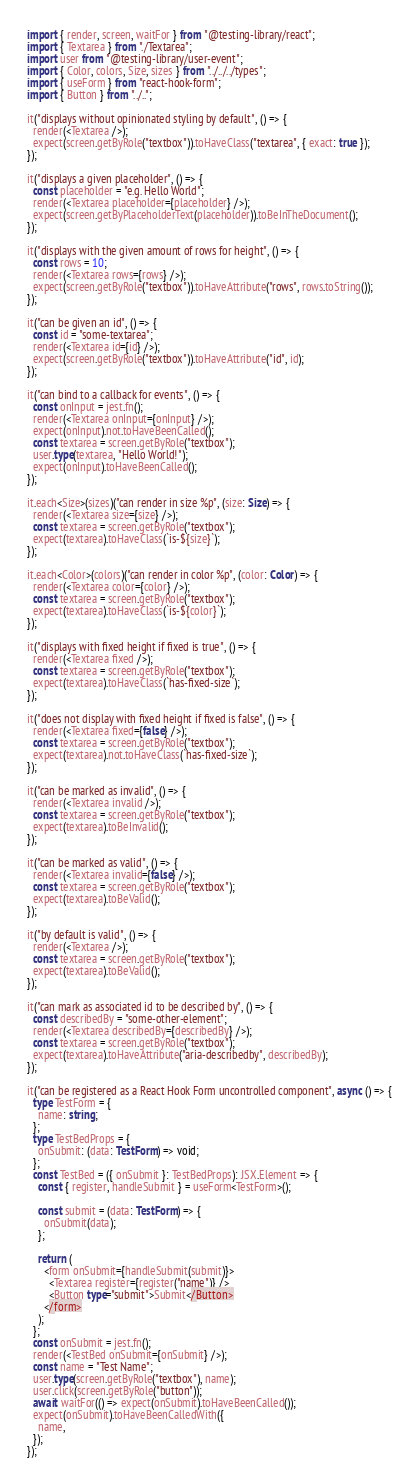Convert code to text. <code><loc_0><loc_0><loc_500><loc_500><_TypeScript_>import { render, screen, waitFor } from "@testing-library/react";
import { Textarea } from "./Textarea";
import user from "@testing-library/user-event";
import { Color, colors, Size, sizes } from "../../../types";
import { useForm } from "react-hook-form";
import { Button } from "../..";

it("displays without opinionated styling by default", () => {
  render(<Textarea />);
  expect(screen.getByRole("textbox")).toHaveClass("textarea", { exact: true });
});

it("displays a given placeholder", () => {
  const placeholder = "e.g. Hello World";
  render(<Textarea placeholder={placeholder} />);
  expect(screen.getByPlaceholderText(placeholder)).toBeInTheDocument();
});

it("displays with the given amount of rows for height", () => {
  const rows = 10;
  render(<Textarea rows={rows} />);
  expect(screen.getByRole("textbox")).toHaveAttribute("rows", rows.toString());
});

it("can be given an id", () => {
  const id = "some-textarea";
  render(<Textarea id={id} />);
  expect(screen.getByRole("textbox")).toHaveAttribute("id", id);
});

it("can bind to a callback for events", () => {
  const onInput = jest.fn();
  render(<Textarea onInput={onInput} />);
  expect(onInput).not.toHaveBeenCalled();
  const textarea = screen.getByRole("textbox");
  user.type(textarea, "Hello World!");
  expect(onInput).toHaveBeenCalled();
});

it.each<Size>(sizes)("can render in size %p", (size: Size) => {
  render(<Textarea size={size} />);
  const textarea = screen.getByRole("textbox");
  expect(textarea).toHaveClass(`is-${size}`);
});

it.each<Color>(colors)("can render in color %p", (color: Color) => {
  render(<Textarea color={color} />);
  const textarea = screen.getByRole("textbox");
  expect(textarea).toHaveClass(`is-${color}`);
});

it("displays with fixed height if fixed is true", () => {
  render(<Textarea fixed />);
  const textarea = screen.getByRole("textbox");
  expect(textarea).toHaveClass(`has-fixed-size`);
});

it("does not display with fixed height if fixed is false", () => {
  render(<Textarea fixed={false} />);
  const textarea = screen.getByRole("textbox");
  expect(textarea).not.toHaveClass(`has-fixed-size`);
});

it("can be marked as invalid", () => {
  render(<Textarea invalid />);
  const textarea = screen.getByRole("textbox");
  expect(textarea).toBeInvalid();
});

it("can be marked as valid", () => {
  render(<Textarea invalid={false} />);
  const textarea = screen.getByRole("textbox");
  expect(textarea).toBeValid();
});

it("by default is valid", () => {
  render(<Textarea />);
  const textarea = screen.getByRole("textbox");
  expect(textarea).toBeValid();
});

it("can mark as associated id to be described by", () => {
  const describedBy = "some-other-element";
  render(<Textarea describedBy={describedBy} />);
  const textarea = screen.getByRole("textbox");
  expect(textarea).toHaveAttribute("aria-describedby", describedBy);
});

it("can be registered as a React Hook Form uncontrolled component", async () => {
  type TestForm = {
    name: string;
  };
  type TestBedProps = {
    onSubmit: (data: TestForm) => void;
  };
  const TestBed = ({ onSubmit }: TestBedProps): JSX.Element => {
    const { register, handleSubmit } = useForm<TestForm>();

    const submit = (data: TestForm) => {
      onSubmit(data);
    };

    return (
      <form onSubmit={handleSubmit(submit)}>
        <Textarea register={register("name")} />
        <Button type="submit">Submit</Button>
      </form>
    );
  };
  const onSubmit = jest.fn();
  render(<TestBed onSubmit={onSubmit} />);
  const name = "Test Name";
  user.type(screen.getByRole("textbox"), name);
  user.click(screen.getByRole("button"));
  await waitFor(() => expect(onSubmit).toHaveBeenCalled());
  expect(onSubmit).toHaveBeenCalledWith({
    name,
  });
});
</code> 